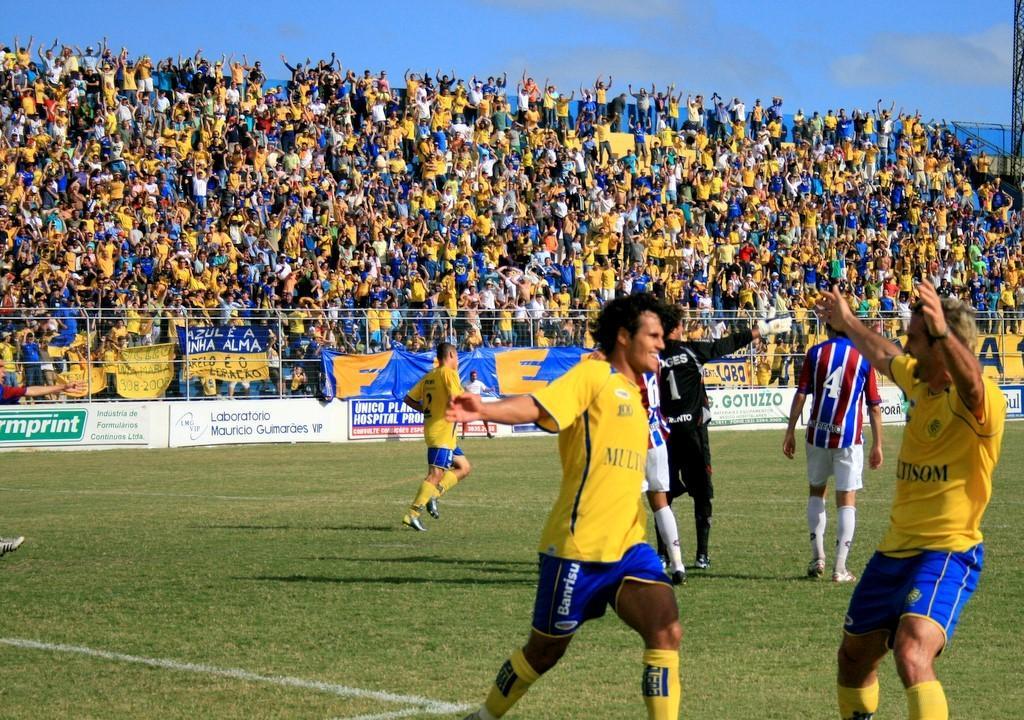How would you summarize this image in a sentence or two? In the we can see a playground with a grass surface on it, we can see some people are running and they are in sports wear and in the background, we can see a wall with some advertisements and behind it, we can see audience are sitting and behind some people are standing and behind them we can see sky with clouds. 